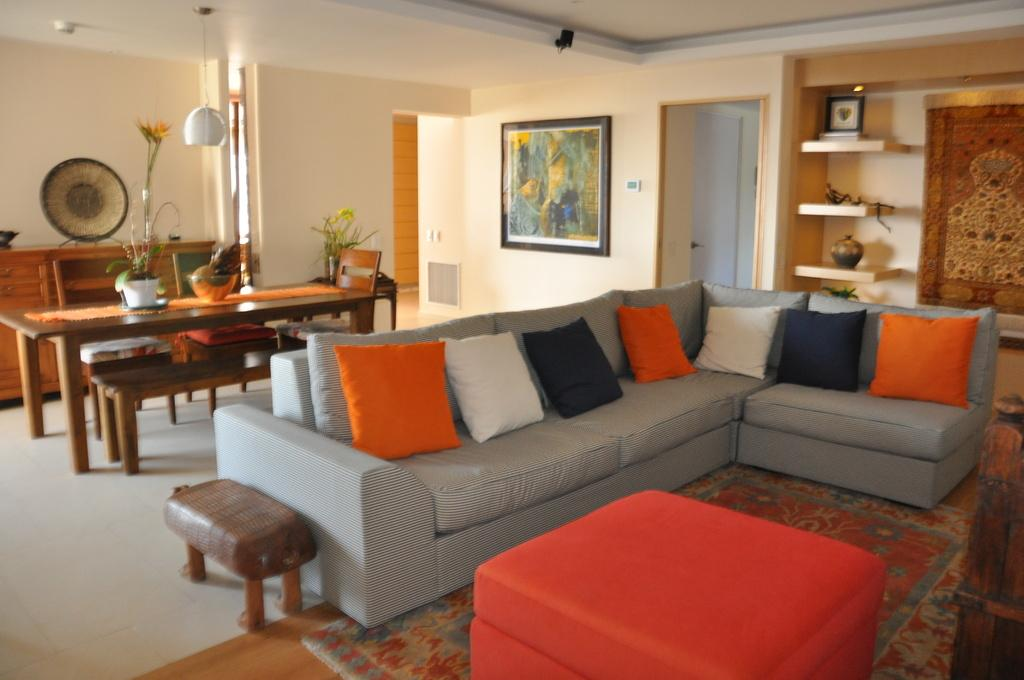What type of furniture is present in the image? There is a sofa with pillows and a dining table in the image. What can be seen on the walls in the image? There are paintings on the wall in the image. What is the title of the painting hanging above the sofa in the image? There is no information about the title of the painting in the provided facts, and the image does not show a painting hanging above the sofa. 